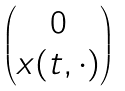<formula> <loc_0><loc_0><loc_500><loc_500>\begin{pmatrix} 0 \\ x ( t , \cdot ) \end{pmatrix}</formula> 